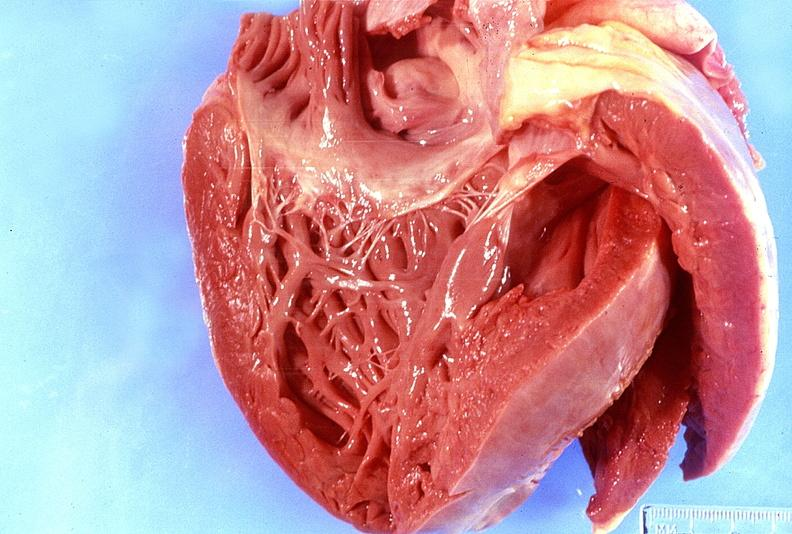s cardiovascular present?
Answer the question using a single word or phrase. Yes 